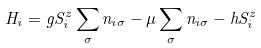<formula> <loc_0><loc_0><loc_500><loc_500>H _ { i } = g S _ { i } ^ { z } \sum _ { \sigma } n _ { i { \sigma } } - \mu \sum _ { \sigma } n _ { i \sigma } - h S _ { i } ^ { z }</formula> 